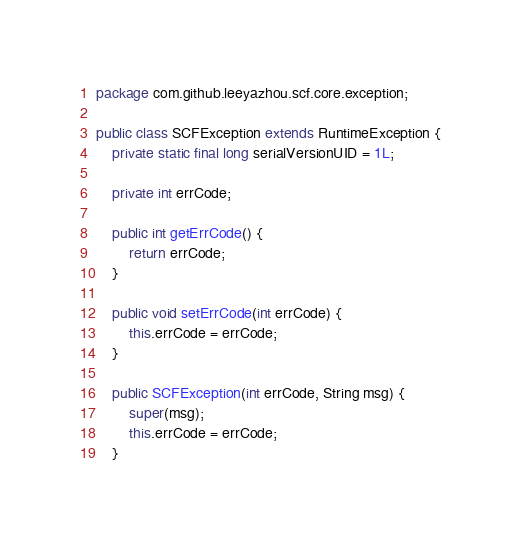Convert code to text. <code><loc_0><loc_0><loc_500><loc_500><_Java_>package com.github.leeyazhou.scf.core.exception;

public class SCFException extends RuntimeException {
	private static final long serialVersionUID = 1L;

	private int errCode;

	public int getErrCode() {
		return errCode;
	}

	public void setErrCode(int errCode) {
		this.errCode = errCode;
	}

	public SCFException(int errCode, String msg) {
		super(msg);
		this.errCode = errCode;
	}
</code> 